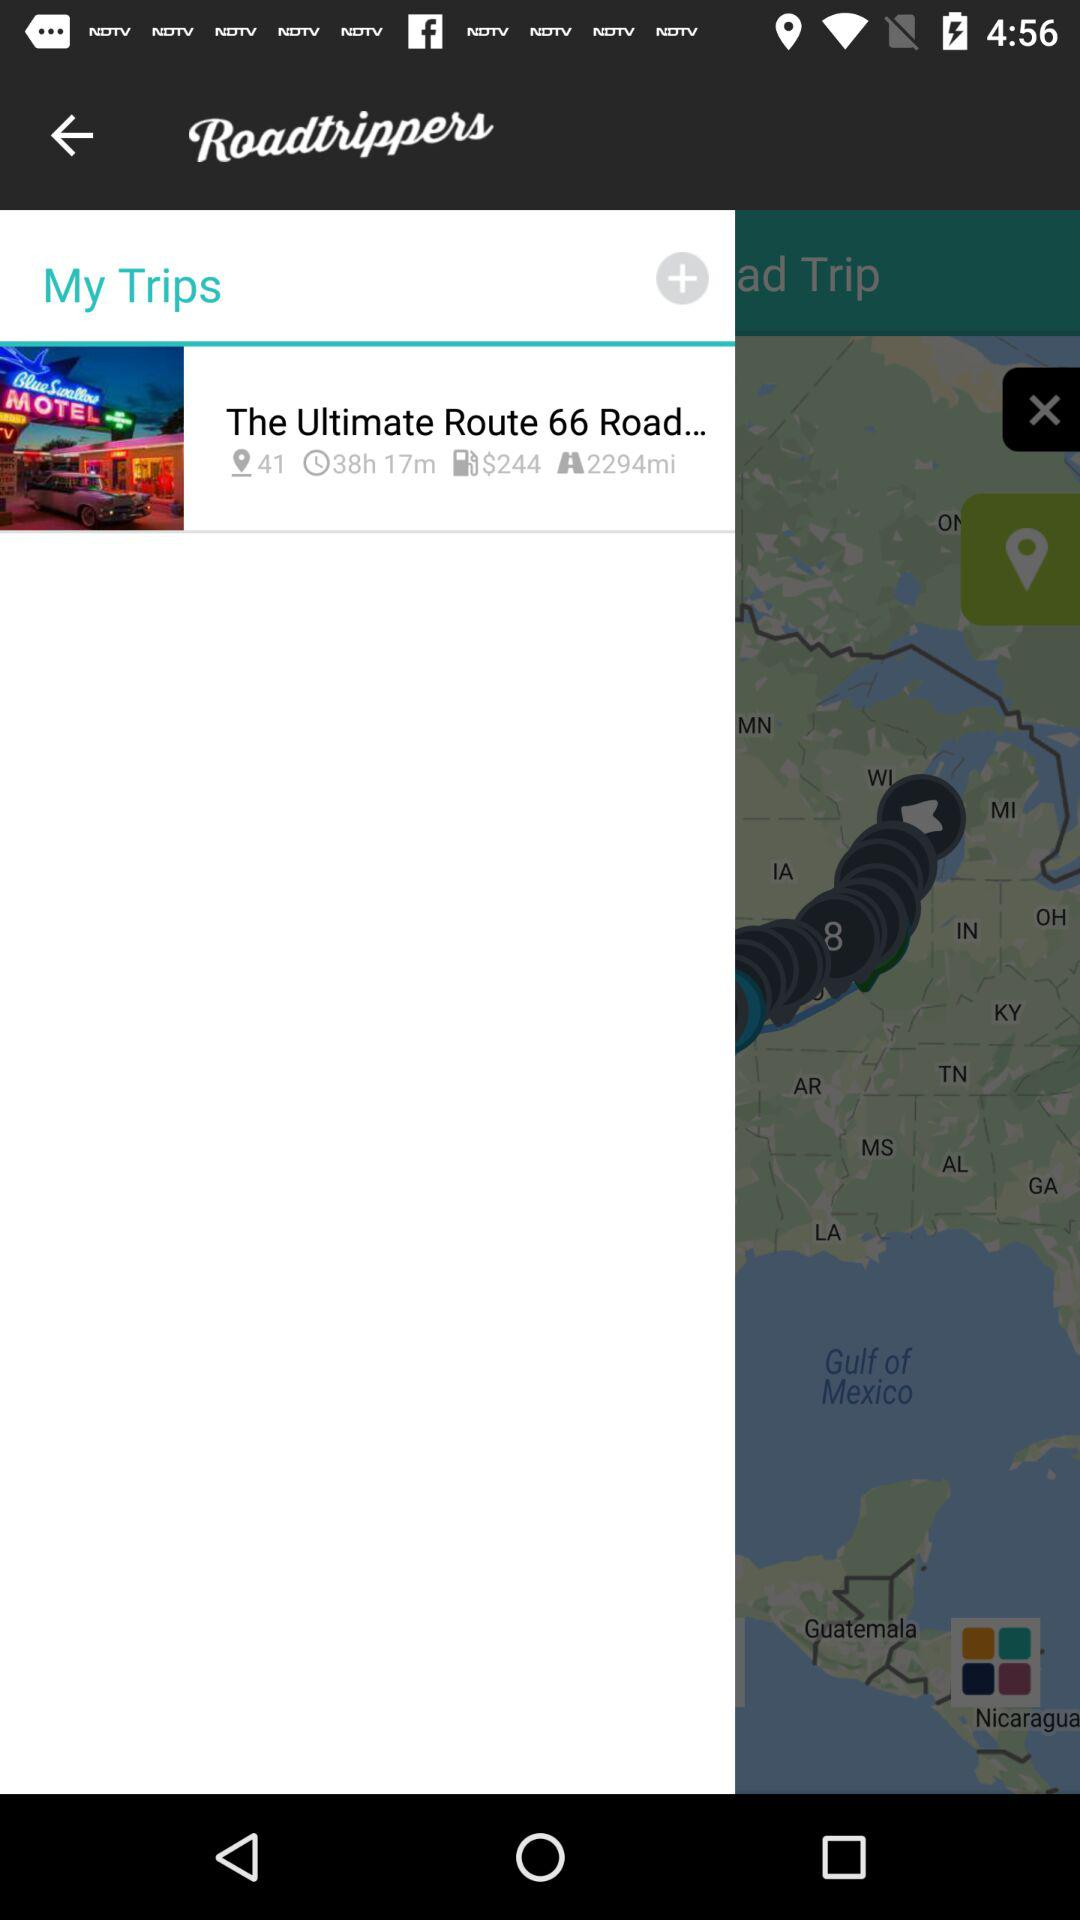How much is the distance of "The Ultimate Route 66 Road"? The distance is 2294 miles. 